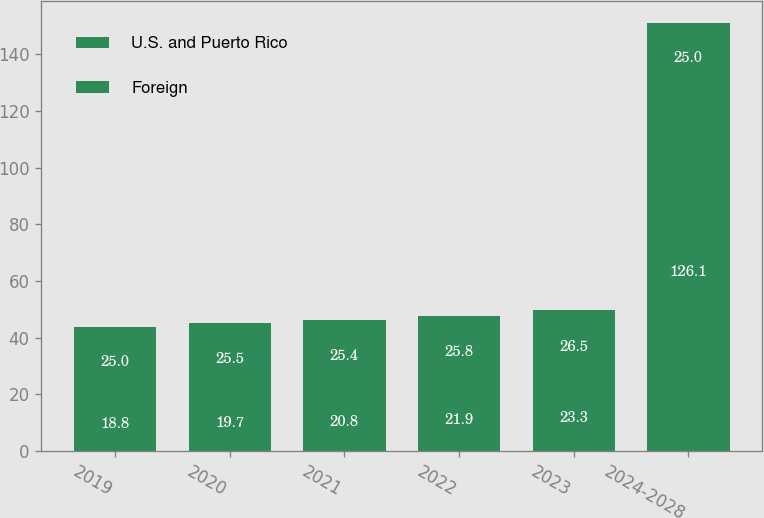Convert chart. <chart><loc_0><loc_0><loc_500><loc_500><stacked_bar_chart><ecel><fcel>2019<fcel>2020<fcel>2021<fcel>2022<fcel>2023<fcel>2024-2028<nl><fcel>U.S. and Puerto Rico<fcel>18.8<fcel>19.7<fcel>20.8<fcel>21.9<fcel>23.3<fcel>126.1<nl><fcel>Foreign<fcel>25<fcel>25.5<fcel>25.4<fcel>25.8<fcel>26.5<fcel>25<nl></chart> 